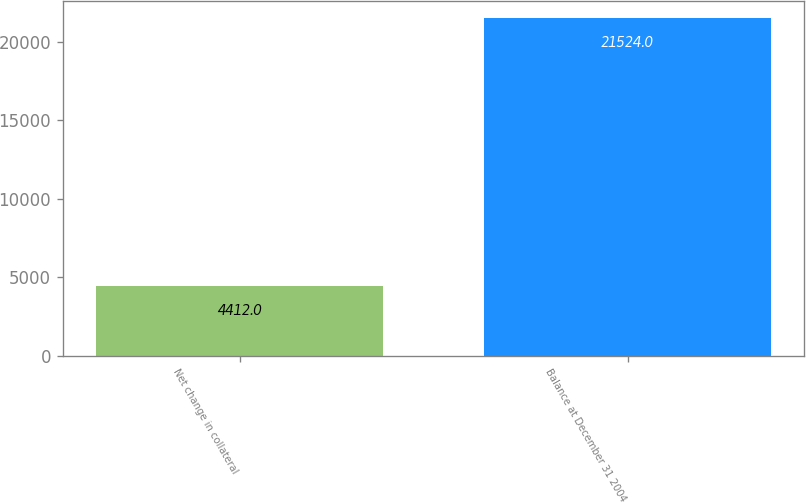Convert chart to OTSL. <chart><loc_0><loc_0><loc_500><loc_500><bar_chart><fcel>Net change in collateral<fcel>Balance at December 31 2004<nl><fcel>4412<fcel>21524<nl></chart> 